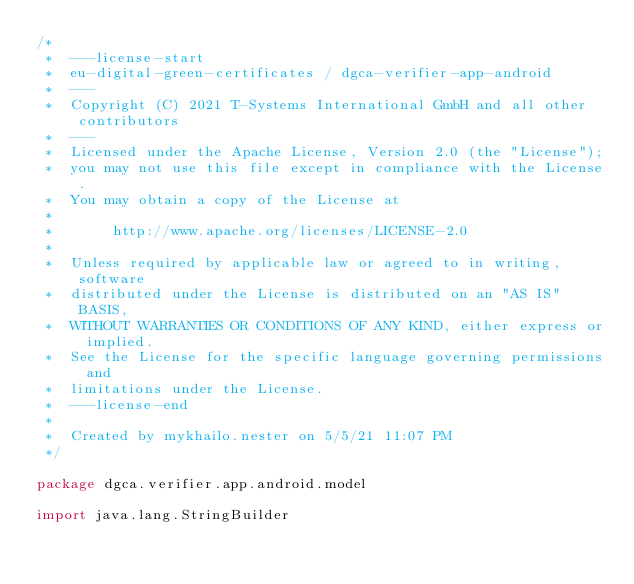<code> <loc_0><loc_0><loc_500><loc_500><_Kotlin_>/*
 *  ---license-start
 *  eu-digital-green-certificates / dgca-verifier-app-android
 *  ---
 *  Copyright (C) 2021 T-Systems International GmbH and all other contributors
 *  ---
 *  Licensed under the Apache License, Version 2.0 (the "License");
 *  you may not use this file except in compliance with the License.
 *  You may obtain a copy of the License at
 *
 *       http://www.apache.org/licenses/LICENSE-2.0
 *
 *  Unless required by applicable law or agreed to in writing, software
 *  distributed under the License is distributed on an "AS IS" BASIS,
 *  WITHOUT WARRANTIES OR CONDITIONS OF ANY KIND, either express or implied.
 *  See the License for the specific language governing permissions and
 *  limitations under the License.
 *  ---license-end
 *
 *  Created by mykhailo.nester on 5/5/21 11:07 PM
 */

package dgca.verifier.app.android.model

import java.lang.StringBuilder
</code> 